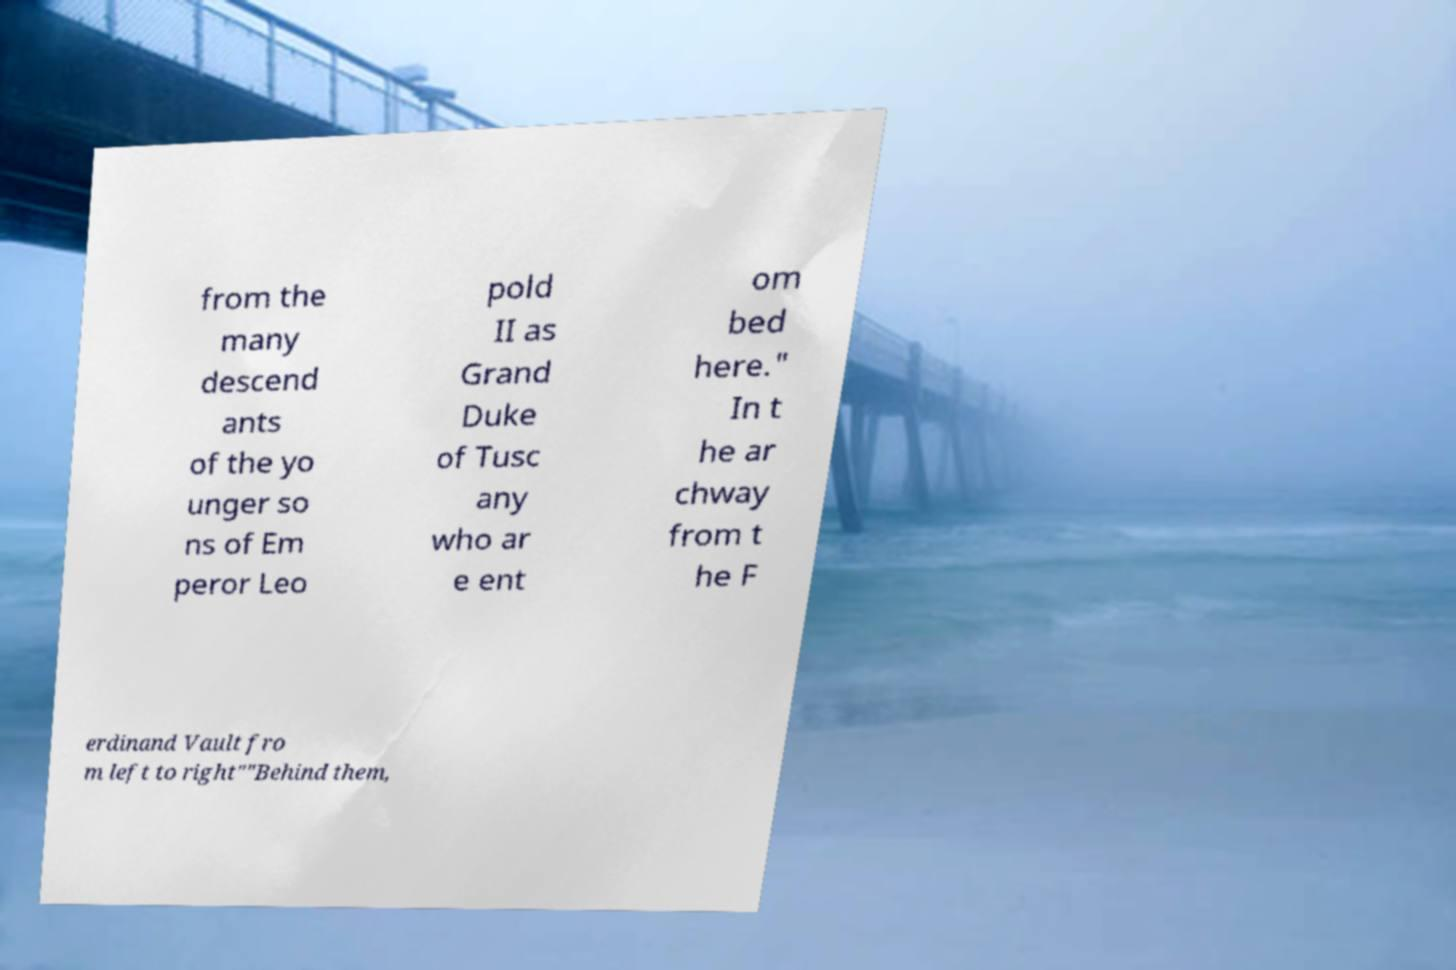There's text embedded in this image that I need extracted. Can you transcribe it verbatim? from the many descend ants of the yo unger so ns of Em peror Leo pold II as Grand Duke of Tusc any who ar e ent om bed here." In t he ar chway from t he F erdinand Vault fro m left to right""Behind them, 